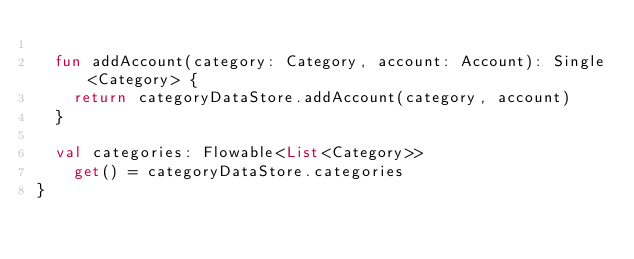<code> <loc_0><loc_0><loc_500><loc_500><_Kotlin_>
  fun addAccount(category: Category, account: Account): Single<Category> {
    return categoryDataStore.addAccount(category, account)
  }

  val categories: Flowable<List<Category>>
    get() = categoryDataStore.categories
}
</code> 